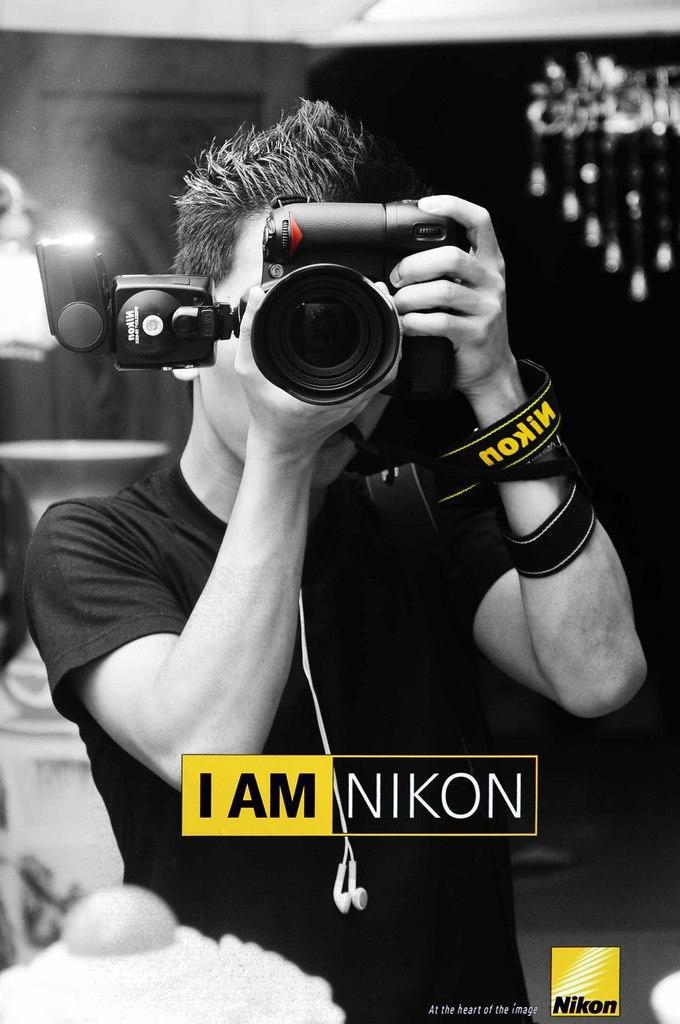Could you give a brief overview of what you see in this image? This is a black and white picture. On the background we can see light. We can see one man wearing black color t shirt holding a camera in his hands. And we can see ¨IAM NIKON¨ on it 